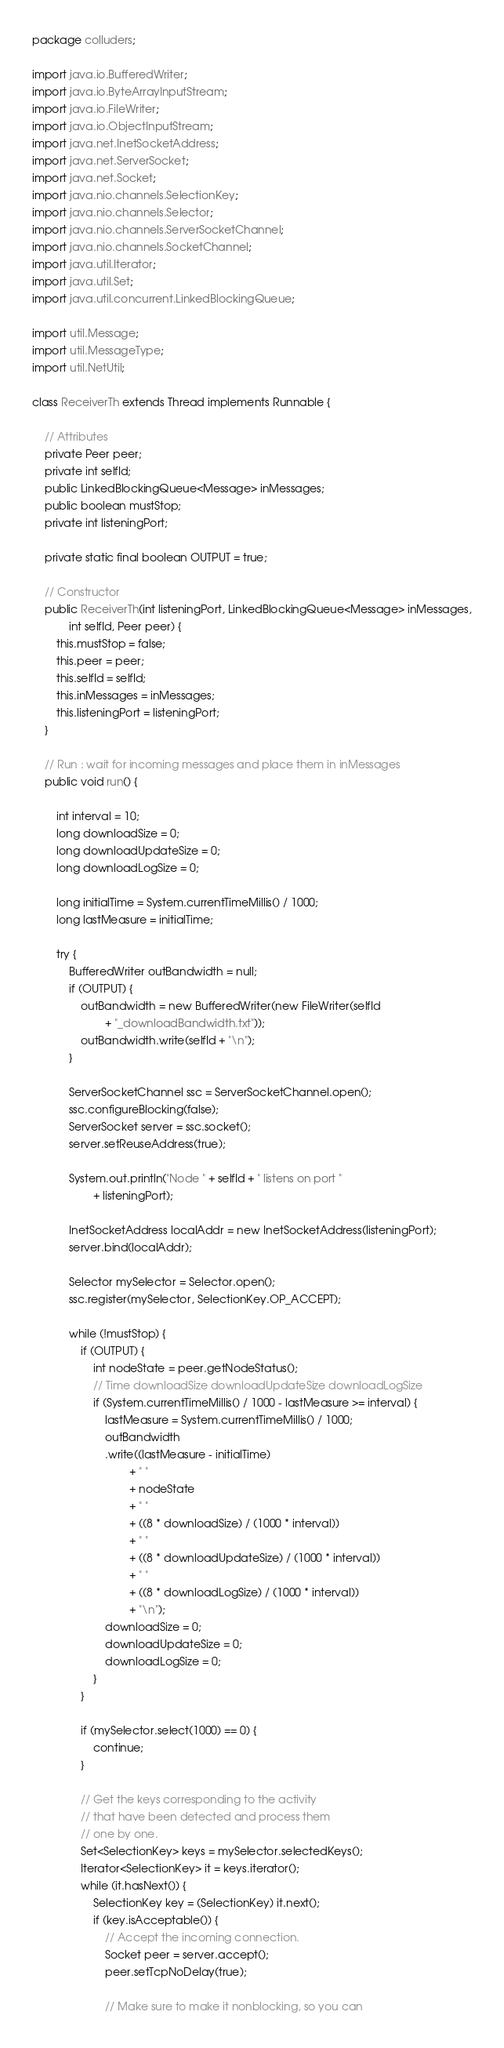Convert code to text. <code><loc_0><loc_0><loc_500><loc_500><_Java_>package colluders;

import java.io.BufferedWriter;
import java.io.ByteArrayInputStream;
import java.io.FileWriter;
import java.io.ObjectInputStream;
import java.net.InetSocketAddress;
import java.net.ServerSocket;
import java.net.Socket;
import java.nio.channels.SelectionKey;
import java.nio.channels.Selector;
import java.nio.channels.ServerSocketChannel;
import java.nio.channels.SocketChannel;
import java.util.Iterator;
import java.util.Set;
import java.util.concurrent.LinkedBlockingQueue;

import util.Message;
import util.MessageType;
import util.NetUtil;

class ReceiverTh extends Thread implements Runnable {

    // Attributes
    private Peer peer;
    private int selfId;
    public LinkedBlockingQueue<Message> inMessages;
    public boolean mustStop;
    private int listeningPort;

    private static final boolean OUTPUT = true;

    // Constructor
    public ReceiverTh(int listeningPort, LinkedBlockingQueue<Message> inMessages,
            int selfId, Peer peer) {
        this.mustStop = false;
        this.peer = peer;
        this.selfId = selfId;
        this.inMessages = inMessages;
        this.listeningPort = listeningPort;
    }

    // Run : wait for incoming messages and place them in inMessages
    public void run() {

        int interval = 10;
        long downloadSize = 0;
        long downloadUpdateSize = 0;
        long downloadLogSize = 0;

        long initialTime = System.currentTimeMillis() / 1000;
        long lastMeasure = initialTime;

        try {
            BufferedWriter outBandwidth = null;
            if (OUTPUT) {
                outBandwidth = new BufferedWriter(new FileWriter(selfId
                        + "_downloadBandwidth.txt"));
                outBandwidth.write(selfId + "\n");
            }

            ServerSocketChannel ssc = ServerSocketChannel.open();
            ssc.configureBlocking(false);
            ServerSocket server = ssc.socket();
            server.setReuseAddress(true);

            System.out.println("Node " + selfId + " listens on port "
                    + listeningPort);

            InetSocketAddress localAddr = new InetSocketAddress(listeningPort);
            server.bind(localAddr);

            Selector mySelector = Selector.open();
            ssc.register(mySelector, SelectionKey.OP_ACCEPT);

            while (!mustStop) {
                if (OUTPUT) {
                    int nodeState = peer.getNodeStatus();
                    // Time downloadSize downloadUpdateSize downloadLogSize
                    if (System.currentTimeMillis() / 1000 - lastMeasure >= interval) {
                        lastMeasure = System.currentTimeMillis() / 1000;
                        outBandwidth
                        .write((lastMeasure - initialTime)
                                + " "
                                + nodeState
                                + " "
                                + ((8 * downloadSize) / (1000 * interval))
                                + " "
                                + ((8 * downloadUpdateSize) / (1000 * interval))
                                + " "
                                + ((8 * downloadLogSize) / (1000 * interval))
                                + "\n");
                        downloadSize = 0;
                        downloadUpdateSize = 0;
                        downloadLogSize = 0;
                    }
                }

                if (mySelector.select(1000) == 0) {
                    continue;
                }

                // Get the keys corresponding to the activity
                // that have been detected and process them
                // one by one.
                Set<SelectionKey> keys = mySelector.selectedKeys();
                Iterator<SelectionKey> it = keys.iterator();
                while (it.hasNext()) {
                    SelectionKey key = (SelectionKey) it.next();
                    if (key.isAcceptable()) {
                        // Accept the incoming connection.
                        Socket peer = server.accept();
                        peer.setTcpNoDelay(true);

                        // Make sure to make it nonblocking, so you can</code> 